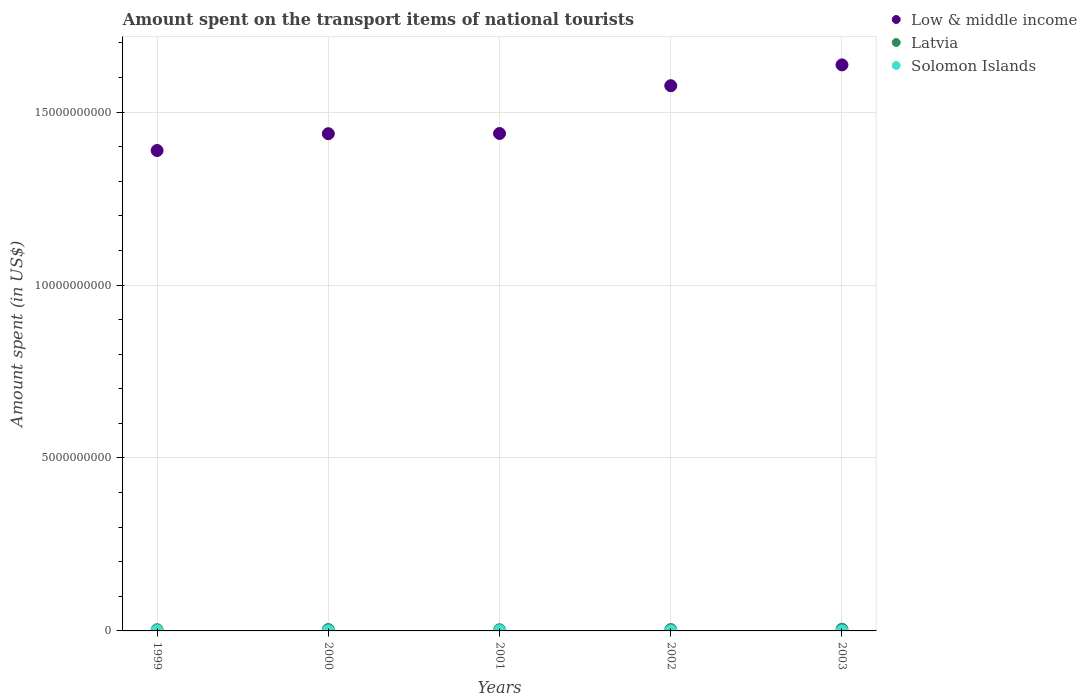Is the number of dotlines equal to the number of legend labels?
Offer a very short reply. Yes. What is the amount spent on the transport items of national tourists in Solomon Islands in 1999?
Your response must be concise. 4.00e+06. Across all years, what is the maximum amount spent on the transport items of national tourists in Solomon Islands?
Give a very brief answer. 4.00e+06. Across all years, what is the minimum amount spent on the transport items of national tourists in Low & middle income?
Your answer should be very brief. 1.39e+1. What is the total amount spent on the transport items of national tourists in Low & middle income in the graph?
Ensure brevity in your answer.  7.48e+1. What is the difference between the amount spent on the transport items of national tourists in Low & middle income in 2000 and that in 2003?
Provide a short and direct response. -1.99e+09. What is the difference between the amount spent on the transport items of national tourists in Latvia in 2002 and the amount spent on the transport items of national tourists in Low & middle income in 2003?
Provide a succinct answer. -1.63e+1. What is the average amount spent on the transport items of national tourists in Low & middle income per year?
Make the answer very short. 1.50e+1. In the year 2000, what is the difference between the amount spent on the transport items of national tourists in Latvia and amount spent on the transport items of national tourists in Low & middle income?
Give a very brief answer. -1.43e+1. What is the ratio of the amount spent on the transport items of national tourists in Low & middle income in 2000 to that in 2002?
Provide a short and direct response. 0.91. Is the amount spent on the transport items of national tourists in Low & middle income in 1999 less than that in 2003?
Offer a very short reply. Yes. What is the difference between the highest and the second highest amount spent on the transport items of national tourists in Latvia?
Offer a very short reply. 8.00e+06. What is the difference between the highest and the lowest amount spent on the transport items of national tourists in Latvia?
Provide a short and direct response. 1.50e+07. In how many years, is the amount spent on the transport items of national tourists in Latvia greater than the average amount spent on the transport items of national tourists in Latvia taken over all years?
Make the answer very short. 3. How many dotlines are there?
Give a very brief answer. 3. What is the difference between two consecutive major ticks on the Y-axis?
Provide a short and direct response. 5.00e+09. Are the values on the major ticks of Y-axis written in scientific E-notation?
Provide a succinct answer. No. Does the graph contain any zero values?
Give a very brief answer. No. Does the graph contain grids?
Ensure brevity in your answer.  Yes. How are the legend labels stacked?
Provide a short and direct response. Vertical. What is the title of the graph?
Offer a terse response. Amount spent on the transport items of national tourists. Does "Andorra" appear as one of the legend labels in the graph?
Ensure brevity in your answer.  No. What is the label or title of the Y-axis?
Ensure brevity in your answer.  Amount spent (in US$). What is the Amount spent (in US$) of Low & middle income in 1999?
Your answer should be compact. 1.39e+1. What is the Amount spent (in US$) in Latvia in 1999?
Keep it short and to the point. 3.50e+07. What is the Amount spent (in US$) of Low & middle income in 2000?
Your answer should be very brief. 1.44e+1. What is the Amount spent (in US$) of Latvia in 2000?
Your answer should be very brief. 4.10e+07. What is the Amount spent (in US$) of Low & middle income in 2001?
Your answer should be compact. 1.44e+1. What is the Amount spent (in US$) of Latvia in 2001?
Make the answer very short. 3.40e+07. What is the Amount spent (in US$) in Solomon Islands in 2001?
Make the answer very short. 3.60e+06. What is the Amount spent (in US$) in Low & middle income in 2002?
Your response must be concise. 1.58e+1. What is the Amount spent (in US$) of Latvia in 2002?
Make the answer very short. 4.00e+07. What is the Amount spent (in US$) of Solomon Islands in 2002?
Keep it short and to the point. 1.00e+05. What is the Amount spent (in US$) in Low & middle income in 2003?
Offer a terse response. 1.64e+1. What is the Amount spent (in US$) in Latvia in 2003?
Provide a short and direct response. 4.90e+07. What is the Amount spent (in US$) in Solomon Islands in 2003?
Provide a succinct answer. 1.00e+05. Across all years, what is the maximum Amount spent (in US$) in Low & middle income?
Provide a short and direct response. 1.64e+1. Across all years, what is the maximum Amount spent (in US$) of Latvia?
Offer a very short reply. 4.90e+07. Across all years, what is the minimum Amount spent (in US$) of Low & middle income?
Provide a succinct answer. 1.39e+1. Across all years, what is the minimum Amount spent (in US$) of Latvia?
Provide a succinct answer. 3.40e+07. Across all years, what is the minimum Amount spent (in US$) in Solomon Islands?
Provide a succinct answer. 1.00e+05. What is the total Amount spent (in US$) of Low & middle income in the graph?
Your response must be concise. 7.48e+1. What is the total Amount spent (in US$) of Latvia in the graph?
Provide a short and direct response. 1.99e+08. What is the total Amount spent (in US$) of Solomon Islands in the graph?
Offer a very short reply. 7.90e+06. What is the difference between the Amount spent (in US$) in Low & middle income in 1999 and that in 2000?
Provide a short and direct response. -4.86e+08. What is the difference between the Amount spent (in US$) in Latvia in 1999 and that in 2000?
Provide a short and direct response. -6.00e+06. What is the difference between the Amount spent (in US$) in Solomon Islands in 1999 and that in 2000?
Offer a very short reply. 3.90e+06. What is the difference between the Amount spent (in US$) in Low & middle income in 1999 and that in 2001?
Your answer should be very brief. -4.92e+08. What is the difference between the Amount spent (in US$) of Low & middle income in 1999 and that in 2002?
Keep it short and to the point. -1.87e+09. What is the difference between the Amount spent (in US$) of Latvia in 1999 and that in 2002?
Provide a short and direct response. -5.00e+06. What is the difference between the Amount spent (in US$) of Solomon Islands in 1999 and that in 2002?
Your answer should be very brief. 3.90e+06. What is the difference between the Amount spent (in US$) of Low & middle income in 1999 and that in 2003?
Give a very brief answer. -2.48e+09. What is the difference between the Amount spent (in US$) of Latvia in 1999 and that in 2003?
Offer a terse response. -1.40e+07. What is the difference between the Amount spent (in US$) in Solomon Islands in 1999 and that in 2003?
Make the answer very short. 3.90e+06. What is the difference between the Amount spent (in US$) in Low & middle income in 2000 and that in 2001?
Provide a short and direct response. -5.99e+06. What is the difference between the Amount spent (in US$) of Latvia in 2000 and that in 2001?
Your answer should be very brief. 7.00e+06. What is the difference between the Amount spent (in US$) in Solomon Islands in 2000 and that in 2001?
Give a very brief answer. -3.50e+06. What is the difference between the Amount spent (in US$) in Low & middle income in 2000 and that in 2002?
Provide a succinct answer. -1.39e+09. What is the difference between the Amount spent (in US$) of Latvia in 2000 and that in 2002?
Provide a short and direct response. 1.00e+06. What is the difference between the Amount spent (in US$) in Solomon Islands in 2000 and that in 2002?
Keep it short and to the point. 0. What is the difference between the Amount spent (in US$) of Low & middle income in 2000 and that in 2003?
Make the answer very short. -1.99e+09. What is the difference between the Amount spent (in US$) of Latvia in 2000 and that in 2003?
Make the answer very short. -8.00e+06. What is the difference between the Amount spent (in US$) of Solomon Islands in 2000 and that in 2003?
Give a very brief answer. 0. What is the difference between the Amount spent (in US$) of Low & middle income in 2001 and that in 2002?
Offer a very short reply. -1.38e+09. What is the difference between the Amount spent (in US$) in Latvia in 2001 and that in 2002?
Offer a terse response. -6.00e+06. What is the difference between the Amount spent (in US$) of Solomon Islands in 2001 and that in 2002?
Your answer should be compact. 3.50e+06. What is the difference between the Amount spent (in US$) of Low & middle income in 2001 and that in 2003?
Give a very brief answer. -1.98e+09. What is the difference between the Amount spent (in US$) in Latvia in 2001 and that in 2003?
Offer a very short reply. -1.50e+07. What is the difference between the Amount spent (in US$) of Solomon Islands in 2001 and that in 2003?
Provide a succinct answer. 3.50e+06. What is the difference between the Amount spent (in US$) in Low & middle income in 2002 and that in 2003?
Your response must be concise. -6.02e+08. What is the difference between the Amount spent (in US$) in Latvia in 2002 and that in 2003?
Make the answer very short. -9.00e+06. What is the difference between the Amount spent (in US$) of Solomon Islands in 2002 and that in 2003?
Provide a succinct answer. 0. What is the difference between the Amount spent (in US$) of Low & middle income in 1999 and the Amount spent (in US$) of Latvia in 2000?
Give a very brief answer. 1.38e+1. What is the difference between the Amount spent (in US$) in Low & middle income in 1999 and the Amount spent (in US$) in Solomon Islands in 2000?
Provide a short and direct response. 1.39e+1. What is the difference between the Amount spent (in US$) in Latvia in 1999 and the Amount spent (in US$) in Solomon Islands in 2000?
Give a very brief answer. 3.49e+07. What is the difference between the Amount spent (in US$) in Low & middle income in 1999 and the Amount spent (in US$) in Latvia in 2001?
Offer a very short reply. 1.39e+1. What is the difference between the Amount spent (in US$) of Low & middle income in 1999 and the Amount spent (in US$) of Solomon Islands in 2001?
Your answer should be very brief. 1.39e+1. What is the difference between the Amount spent (in US$) of Latvia in 1999 and the Amount spent (in US$) of Solomon Islands in 2001?
Offer a terse response. 3.14e+07. What is the difference between the Amount spent (in US$) of Low & middle income in 1999 and the Amount spent (in US$) of Latvia in 2002?
Your answer should be compact. 1.38e+1. What is the difference between the Amount spent (in US$) in Low & middle income in 1999 and the Amount spent (in US$) in Solomon Islands in 2002?
Your response must be concise. 1.39e+1. What is the difference between the Amount spent (in US$) of Latvia in 1999 and the Amount spent (in US$) of Solomon Islands in 2002?
Give a very brief answer. 3.49e+07. What is the difference between the Amount spent (in US$) in Low & middle income in 1999 and the Amount spent (in US$) in Latvia in 2003?
Your response must be concise. 1.38e+1. What is the difference between the Amount spent (in US$) in Low & middle income in 1999 and the Amount spent (in US$) in Solomon Islands in 2003?
Your answer should be very brief. 1.39e+1. What is the difference between the Amount spent (in US$) of Latvia in 1999 and the Amount spent (in US$) of Solomon Islands in 2003?
Your answer should be compact. 3.49e+07. What is the difference between the Amount spent (in US$) of Low & middle income in 2000 and the Amount spent (in US$) of Latvia in 2001?
Your answer should be compact. 1.43e+1. What is the difference between the Amount spent (in US$) of Low & middle income in 2000 and the Amount spent (in US$) of Solomon Islands in 2001?
Make the answer very short. 1.44e+1. What is the difference between the Amount spent (in US$) of Latvia in 2000 and the Amount spent (in US$) of Solomon Islands in 2001?
Offer a very short reply. 3.74e+07. What is the difference between the Amount spent (in US$) of Low & middle income in 2000 and the Amount spent (in US$) of Latvia in 2002?
Provide a succinct answer. 1.43e+1. What is the difference between the Amount spent (in US$) of Low & middle income in 2000 and the Amount spent (in US$) of Solomon Islands in 2002?
Your answer should be compact. 1.44e+1. What is the difference between the Amount spent (in US$) of Latvia in 2000 and the Amount spent (in US$) of Solomon Islands in 2002?
Give a very brief answer. 4.09e+07. What is the difference between the Amount spent (in US$) of Low & middle income in 2000 and the Amount spent (in US$) of Latvia in 2003?
Provide a succinct answer. 1.43e+1. What is the difference between the Amount spent (in US$) in Low & middle income in 2000 and the Amount spent (in US$) in Solomon Islands in 2003?
Your response must be concise. 1.44e+1. What is the difference between the Amount spent (in US$) of Latvia in 2000 and the Amount spent (in US$) of Solomon Islands in 2003?
Offer a very short reply. 4.09e+07. What is the difference between the Amount spent (in US$) in Low & middle income in 2001 and the Amount spent (in US$) in Latvia in 2002?
Ensure brevity in your answer.  1.43e+1. What is the difference between the Amount spent (in US$) in Low & middle income in 2001 and the Amount spent (in US$) in Solomon Islands in 2002?
Make the answer very short. 1.44e+1. What is the difference between the Amount spent (in US$) of Latvia in 2001 and the Amount spent (in US$) of Solomon Islands in 2002?
Make the answer very short. 3.39e+07. What is the difference between the Amount spent (in US$) of Low & middle income in 2001 and the Amount spent (in US$) of Latvia in 2003?
Your response must be concise. 1.43e+1. What is the difference between the Amount spent (in US$) in Low & middle income in 2001 and the Amount spent (in US$) in Solomon Islands in 2003?
Ensure brevity in your answer.  1.44e+1. What is the difference between the Amount spent (in US$) of Latvia in 2001 and the Amount spent (in US$) of Solomon Islands in 2003?
Keep it short and to the point. 3.39e+07. What is the difference between the Amount spent (in US$) of Low & middle income in 2002 and the Amount spent (in US$) of Latvia in 2003?
Your answer should be very brief. 1.57e+1. What is the difference between the Amount spent (in US$) of Low & middle income in 2002 and the Amount spent (in US$) of Solomon Islands in 2003?
Ensure brevity in your answer.  1.58e+1. What is the difference between the Amount spent (in US$) in Latvia in 2002 and the Amount spent (in US$) in Solomon Islands in 2003?
Make the answer very short. 3.99e+07. What is the average Amount spent (in US$) in Low & middle income per year?
Your answer should be very brief. 1.50e+1. What is the average Amount spent (in US$) in Latvia per year?
Ensure brevity in your answer.  3.98e+07. What is the average Amount spent (in US$) of Solomon Islands per year?
Provide a succinct answer. 1.58e+06. In the year 1999, what is the difference between the Amount spent (in US$) in Low & middle income and Amount spent (in US$) in Latvia?
Ensure brevity in your answer.  1.39e+1. In the year 1999, what is the difference between the Amount spent (in US$) of Low & middle income and Amount spent (in US$) of Solomon Islands?
Provide a short and direct response. 1.39e+1. In the year 1999, what is the difference between the Amount spent (in US$) of Latvia and Amount spent (in US$) of Solomon Islands?
Your answer should be compact. 3.10e+07. In the year 2000, what is the difference between the Amount spent (in US$) of Low & middle income and Amount spent (in US$) of Latvia?
Ensure brevity in your answer.  1.43e+1. In the year 2000, what is the difference between the Amount spent (in US$) of Low & middle income and Amount spent (in US$) of Solomon Islands?
Ensure brevity in your answer.  1.44e+1. In the year 2000, what is the difference between the Amount spent (in US$) of Latvia and Amount spent (in US$) of Solomon Islands?
Your response must be concise. 4.09e+07. In the year 2001, what is the difference between the Amount spent (in US$) of Low & middle income and Amount spent (in US$) of Latvia?
Ensure brevity in your answer.  1.43e+1. In the year 2001, what is the difference between the Amount spent (in US$) of Low & middle income and Amount spent (in US$) of Solomon Islands?
Ensure brevity in your answer.  1.44e+1. In the year 2001, what is the difference between the Amount spent (in US$) in Latvia and Amount spent (in US$) in Solomon Islands?
Offer a very short reply. 3.04e+07. In the year 2002, what is the difference between the Amount spent (in US$) of Low & middle income and Amount spent (in US$) of Latvia?
Your answer should be very brief. 1.57e+1. In the year 2002, what is the difference between the Amount spent (in US$) of Low & middle income and Amount spent (in US$) of Solomon Islands?
Your response must be concise. 1.58e+1. In the year 2002, what is the difference between the Amount spent (in US$) of Latvia and Amount spent (in US$) of Solomon Islands?
Offer a very short reply. 3.99e+07. In the year 2003, what is the difference between the Amount spent (in US$) in Low & middle income and Amount spent (in US$) in Latvia?
Provide a succinct answer. 1.63e+1. In the year 2003, what is the difference between the Amount spent (in US$) of Low & middle income and Amount spent (in US$) of Solomon Islands?
Provide a short and direct response. 1.64e+1. In the year 2003, what is the difference between the Amount spent (in US$) in Latvia and Amount spent (in US$) in Solomon Islands?
Provide a succinct answer. 4.89e+07. What is the ratio of the Amount spent (in US$) in Low & middle income in 1999 to that in 2000?
Your answer should be very brief. 0.97. What is the ratio of the Amount spent (in US$) in Latvia in 1999 to that in 2000?
Your answer should be very brief. 0.85. What is the ratio of the Amount spent (in US$) of Solomon Islands in 1999 to that in 2000?
Your response must be concise. 40. What is the ratio of the Amount spent (in US$) in Low & middle income in 1999 to that in 2001?
Give a very brief answer. 0.97. What is the ratio of the Amount spent (in US$) in Latvia in 1999 to that in 2001?
Ensure brevity in your answer.  1.03. What is the ratio of the Amount spent (in US$) of Low & middle income in 1999 to that in 2002?
Provide a succinct answer. 0.88. What is the ratio of the Amount spent (in US$) of Solomon Islands in 1999 to that in 2002?
Offer a very short reply. 40. What is the ratio of the Amount spent (in US$) in Low & middle income in 1999 to that in 2003?
Keep it short and to the point. 0.85. What is the ratio of the Amount spent (in US$) of Latvia in 1999 to that in 2003?
Offer a very short reply. 0.71. What is the ratio of the Amount spent (in US$) of Solomon Islands in 1999 to that in 2003?
Give a very brief answer. 40. What is the ratio of the Amount spent (in US$) of Low & middle income in 2000 to that in 2001?
Give a very brief answer. 1. What is the ratio of the Amount spent (in US$) in Latvia in 2000 to that in 2001?
Your response must be concise. 1.21. What is the ratio of the Amount spent (in US$) in Solomon Islands in 2000 to that in 2001?
Ensure brevity in your answer.  0.03. What is the ratio of the Amount spent (in US$) of Low & middle income in 2000 to that in 2002?
Provide a succinct answer. 0.91. What is the ratio of the Amount spent (in US$) of Latvia in 2000 to that in 2002?
Give a very brief answer. 1.02. What is the ratio of the Amount spent (in US$) of Solomon Islands in 2000 to that in 2002?
Your answer should be compact. 1. What is the ratio of the Amount spent (in US$) in Low & middle income in 2000 to that in 2003?
Ensure brevity in your answer.  0.88. What is the ratio of the Amount spent (in US$) in Latvia in 2000 to that in 2003?
Ensure brevity in your answer.  0.84. What is the ratio of the Amount spent (in US$) of Solomon Islands in 2000 to that in 2003?
Offer a terse response. 1. What is the ratio of the Amount spent (in US$) of Low & middle income in 2001 to that in 2002?
Your answer should be compact. 0.91. What is the ratio of the Amount spent (in US$) in Latvia in 2001 to that in 2002?
Keep it short and to the point. 0.85. What is the ratio of the Amount spent (in US$) in Solomon Islands in 2001 to that in 2002?
Provide a short and direct response. 36. What is the ratio of the Amount spent (in US$) of Low & middle income in 2001 to that in 2003?
Offer a terse response. 0.88. What is the ratio of the Amount spent (in US$) of Latvia in 2001 to that in 2003?
Ensure brevity in your answer.  0.69. What is the ratio of the Amount spent (in US$) of Low & middle income in 2002 to that in 2003?
Ensure brevity in your answer.  0.96. What is the ratio of the Amount spent (in US$) in Latvia in 2002 to that in 2003?
Your response must be concise. 0.82. What is the ratio of the Amount spent (in US$) of Solomon Islands in 2002 to that in 2003?
Keep it short and to the point. 1. What is the difference between the highest and the second highest Amount spent (in US$) in Low & middle income?
Your answer should be compact. 6.02e+08. What is the difference between the highest and the second highest Amount spent (in US$) in Solomon Islands?
Make the answer very short. 4.00e+05. What is the difference between the highest and the lowest Amount spent (in US$) in Low & middle income?
Ensure brevity in your answer.  2.48e+09. What is the difference between the highest and the lowest Amount spent (in US$) in Latvia?
Give a very brief answer. 1.50e+07. What is the difference between the highest and the lowest Amount spent (in US$) of Solomon Islands?
Ensure brevity in your answer.  3.90e+06. 